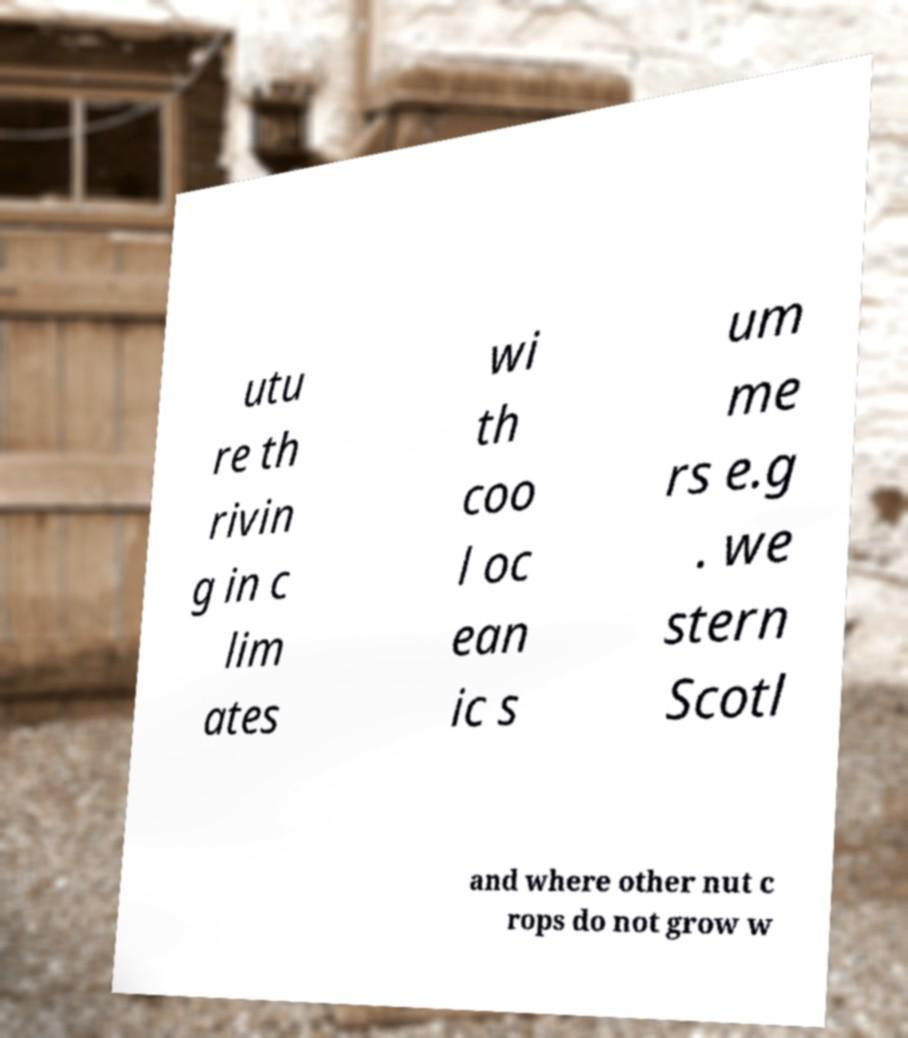For documentation purposes, I need the text within this image transcribed. Could you provide that? utu re th rivin g in c lim ates wi th coo l oc ean ic s um me rs e.g . we stern Scotl and where other nut c rops do not grow w 